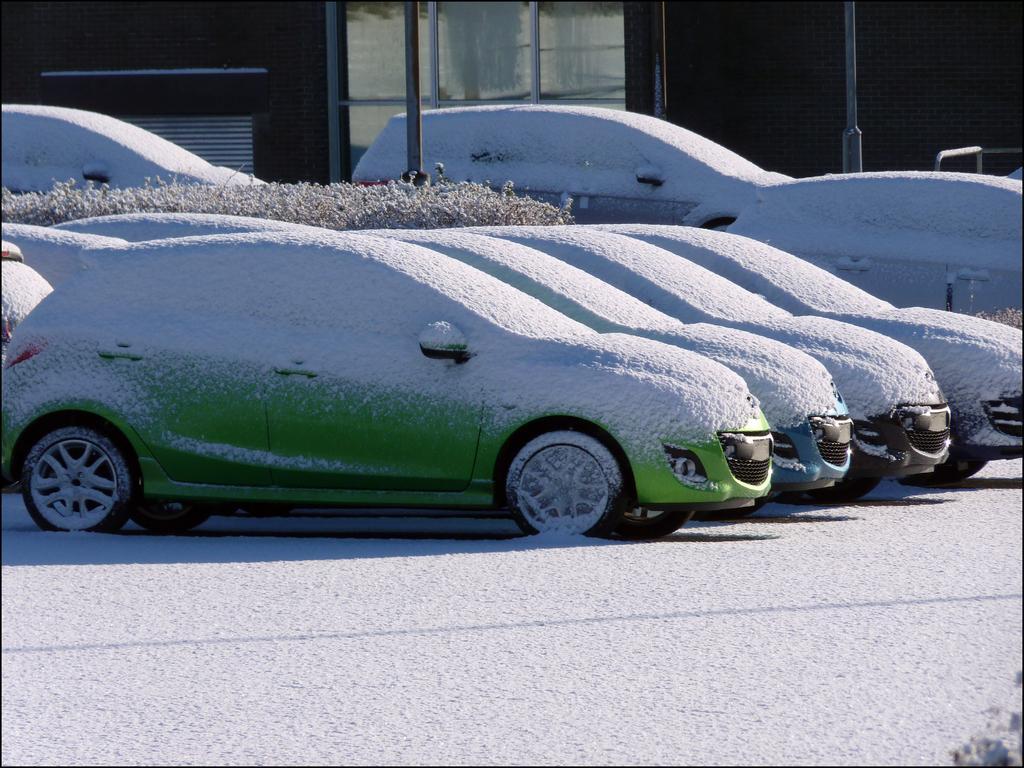Could you give a brief overview of what you see in this image? In the center of the image there are cars covered by snow. In the background there is a building and poles. 